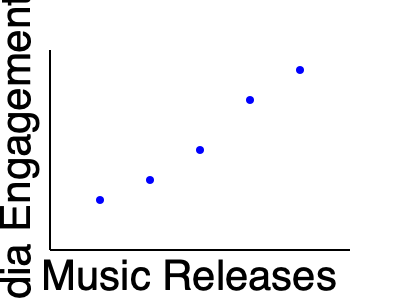Based on the scatter plot showing the correlation between Dina Saeva's music releases and her social media engagement, what trend can be observed, and how might this information be useful for her upcoming music projects? To answer this question, let's analyze the scatter plot step-by-step:

1. X-axis represents Music Releases, increasing from left to right.
2. Y-axis represents Social Media Engagement in millions, increasing from bottom to top.
3. Each blue dot represents a data point correlating a music release with social media engagement.

Observing the plot:
4. The dots form a clear downward trend from left to right.
5. This indicates a negative correlation between the number of music releases and social media engagement.
6. As Dina Saeva releases more music (moving right on the x-axis), her social media engagement tends to increase (moving up on the y-axis).

Interpreting the trend:
7. This suggests that Dina Saeva's music releases are positively impacting her social media presence.
8. Each new release seems to boost her engagement metrics.

Usefulness for upcoming projects:
9. This trend implies that continuing to release music could further increase Dina's social media engagement.
10. It may encourage her team to maintain or increase the frequency of music releases.
11. The data could be used to predict potential engagement levels for future releases.
12. It might also inform marketing strategies, timing of releases, or content creation to maximize engagement.
Answer: Positive correlation; suggests continued music releases could further boost social media engagement. 